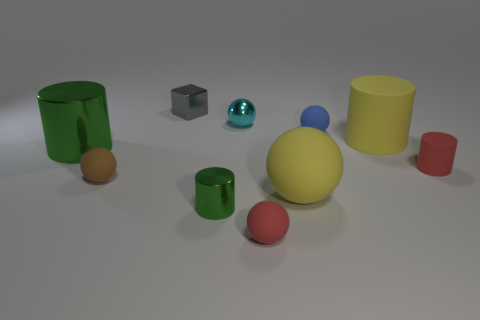Can you describe the lighting conditions in the scene? The lighting in the scene appears to be diffused and soft, likely from an overhead source. Shadows are soft-edged and not very pronounced, indicating that the light source is not direct or harsh. This could be an indoor setting with ambient lighting. There's a slight reflection on the surface beneath the objects, which suggests that the source of light is fairly strong but scattered. 